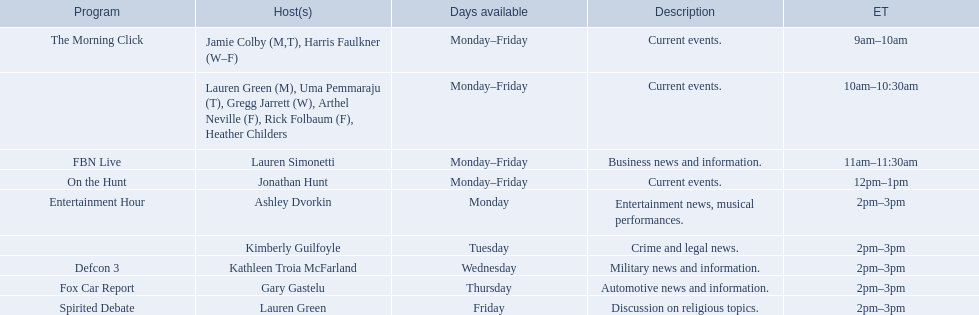What are the names of all the hosts? Jamie Colby (M,T), Harris Faulkner (W–F), Lauren Green (M), Uma Pemmaraju (T), Gregg Jarrett (W), Arthel Neville (F), Rick Folbaum (F), Heather Childers, Lauren Simonetti, Jonathan Hunt, Ashley Dvorkin, Kimberly Guilfoyle, Kathleen Troia McFarland, Gary Gastelu, Lauren Green. What hosts have a show on friday? Jamie Colby (M,T), Harris Faulkner (W–F), Lauren Green (M), Uma Pemmaraju (T), Gregg Jarrett (W), Arthel Neville (F), Rick Folbaum (F), Heather Childers, Lauren Simonetti, Jonathan Hunt, Lauren Green. Of these hosts, which is the only host with only friday available? Lauren Green. 